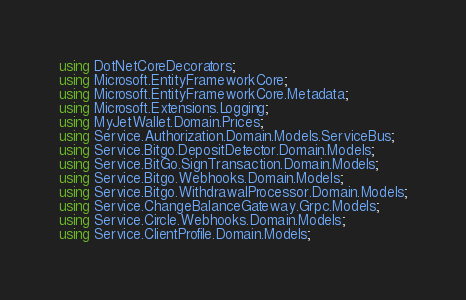<code> <loc_0><loc_0><loc_500><loc_500><_C#_>using DotNetCoreDecorators;
using Microsoft.EntityFrameworkCore;
using Microsoft.EntityFrameworkCore.Metadata;
using Microsoft.Extensions.Logging;
using MyJetWallet.Domain.Prices;
using Service.Authorization.Domain.Models.ServiceBus;
using Service.Bitgo.DepositDetector.Domain.Models;
using Service.BitGo.SignTransaction.Domain.Models;
using Service.Bitgo.Webhooks.Domain.Models;
using Service.Bitgo.WithdrawalProcessor.Domain.Models;
using Service.ChangeBalanceGateway.Grpc.Models;
using Service.Circle.Webhooks.Domain.Models;
using Service.ClientProfile.Domain.Models;</code> 